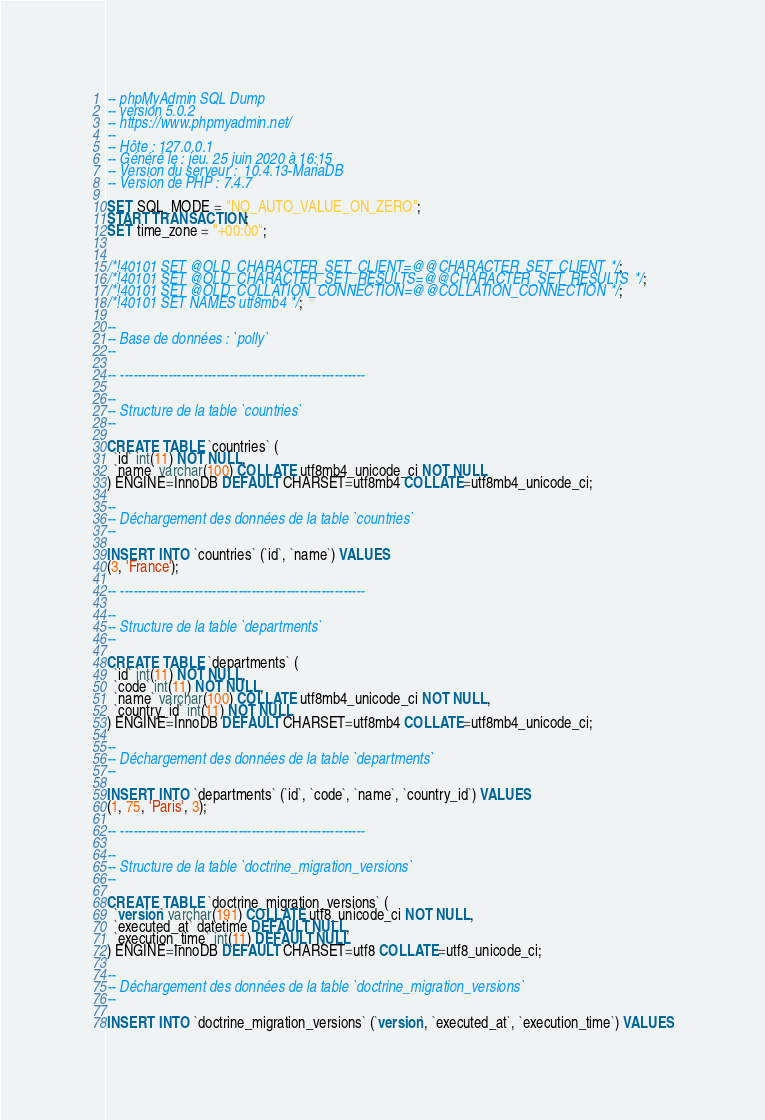<code> <loc_0><loc_0><loc_500><loc_500><_SQL_>-- phpMyAdmin SQL Dump
-- version 5.0.2
-- https://www.phpmyadmin.net/
--
-- Hôte : 127.0.0.1
-- Généré le : jeu. 25 juin 2020 à 16:15
-- Version du serveur :  10.4.13-MariaDB
-- Version de PHP : 7.4.7

SET SQL_MODE = "NO_AUTO_VALUE_ON_ZERO";
START TRANSACTION;
SET time_zone = "+00:00";


/*!40101 SET @OLD_CHARACTER_SET_CLIENT=@@CHARACTER_SET_CLIENT */;
/*!40101 SET @OLD_CHARACTER_SET_RESULTS=@@CHARACTER_SET_RESULTS */;
/*!40101 SET @OLD_COLLATION_CONNECTION=@@COLLATION_CONNECTION */;
/*!40101 SET NAMES utf8mb4 */;

--
-- Base de données : `polly`
--

-- --------------------------------------------------------

--
-- Structure de la table `countries`
--

CREATE TABLE `countries` (
  `id` int(11) NOT NULL,
  `name` varchar(100) COLLATE utf8mb4_unicode_ci NOT NULL
) ENGINE=InnoDB DEFAULT CHARSET=utf8mb4 COLLATE=utf8mb4_unicode_ci;

--
-- Déchargement des données de la table `countries`
--

INSERT INTO `countries` (`id`, `name`) VALUES
(3, 'France');

-- --------------------------------------------------------

--
-- Structure de la table `departments`
--

CREATE TABLE `departments` (
  `id` int(11) NOT NULL,
  `code` int(11) NOT NULL,
  `name` varchar(100) COLLATE utf8mb4_unicode_ci NOT NULL,
  `country_id` int(11) NOT NULL
) ENGINE=InnoDB DEFAULT CHARSET=utf8mb4 COLLATE=utf8mb4_unicode_ci;

--
-- Déchargement des données de la table `departments`
--

INSERT INTO `departments` (`id`, `code`, `name`, `country_id`) VALUES
(1, 75, 'Paris', 3);

-- --------------------------------------------------------

--
-- Structure de la table `doctrine_migration_versions`
--

CREATE TABLE `doctrine_migration_versions` (
  `version` varchar(191) COLLATE utf8_unicode_ci NOT NULL,
  `executed_at` datetime DEFAULT NULL,
  `execution_time` int(11) DEFAULT NULL
) ENGINE=InnoDB DEFAULT CHARSET=utf8 COLLATE=utf8_unicode_ci;

--
-- Déchargement des données de la table `doctrine_migration_versions`
--

INSERT INTO `doctrine_migration_versions` (`version`, `executed_at`, `execution_time`) VALUES</code> 